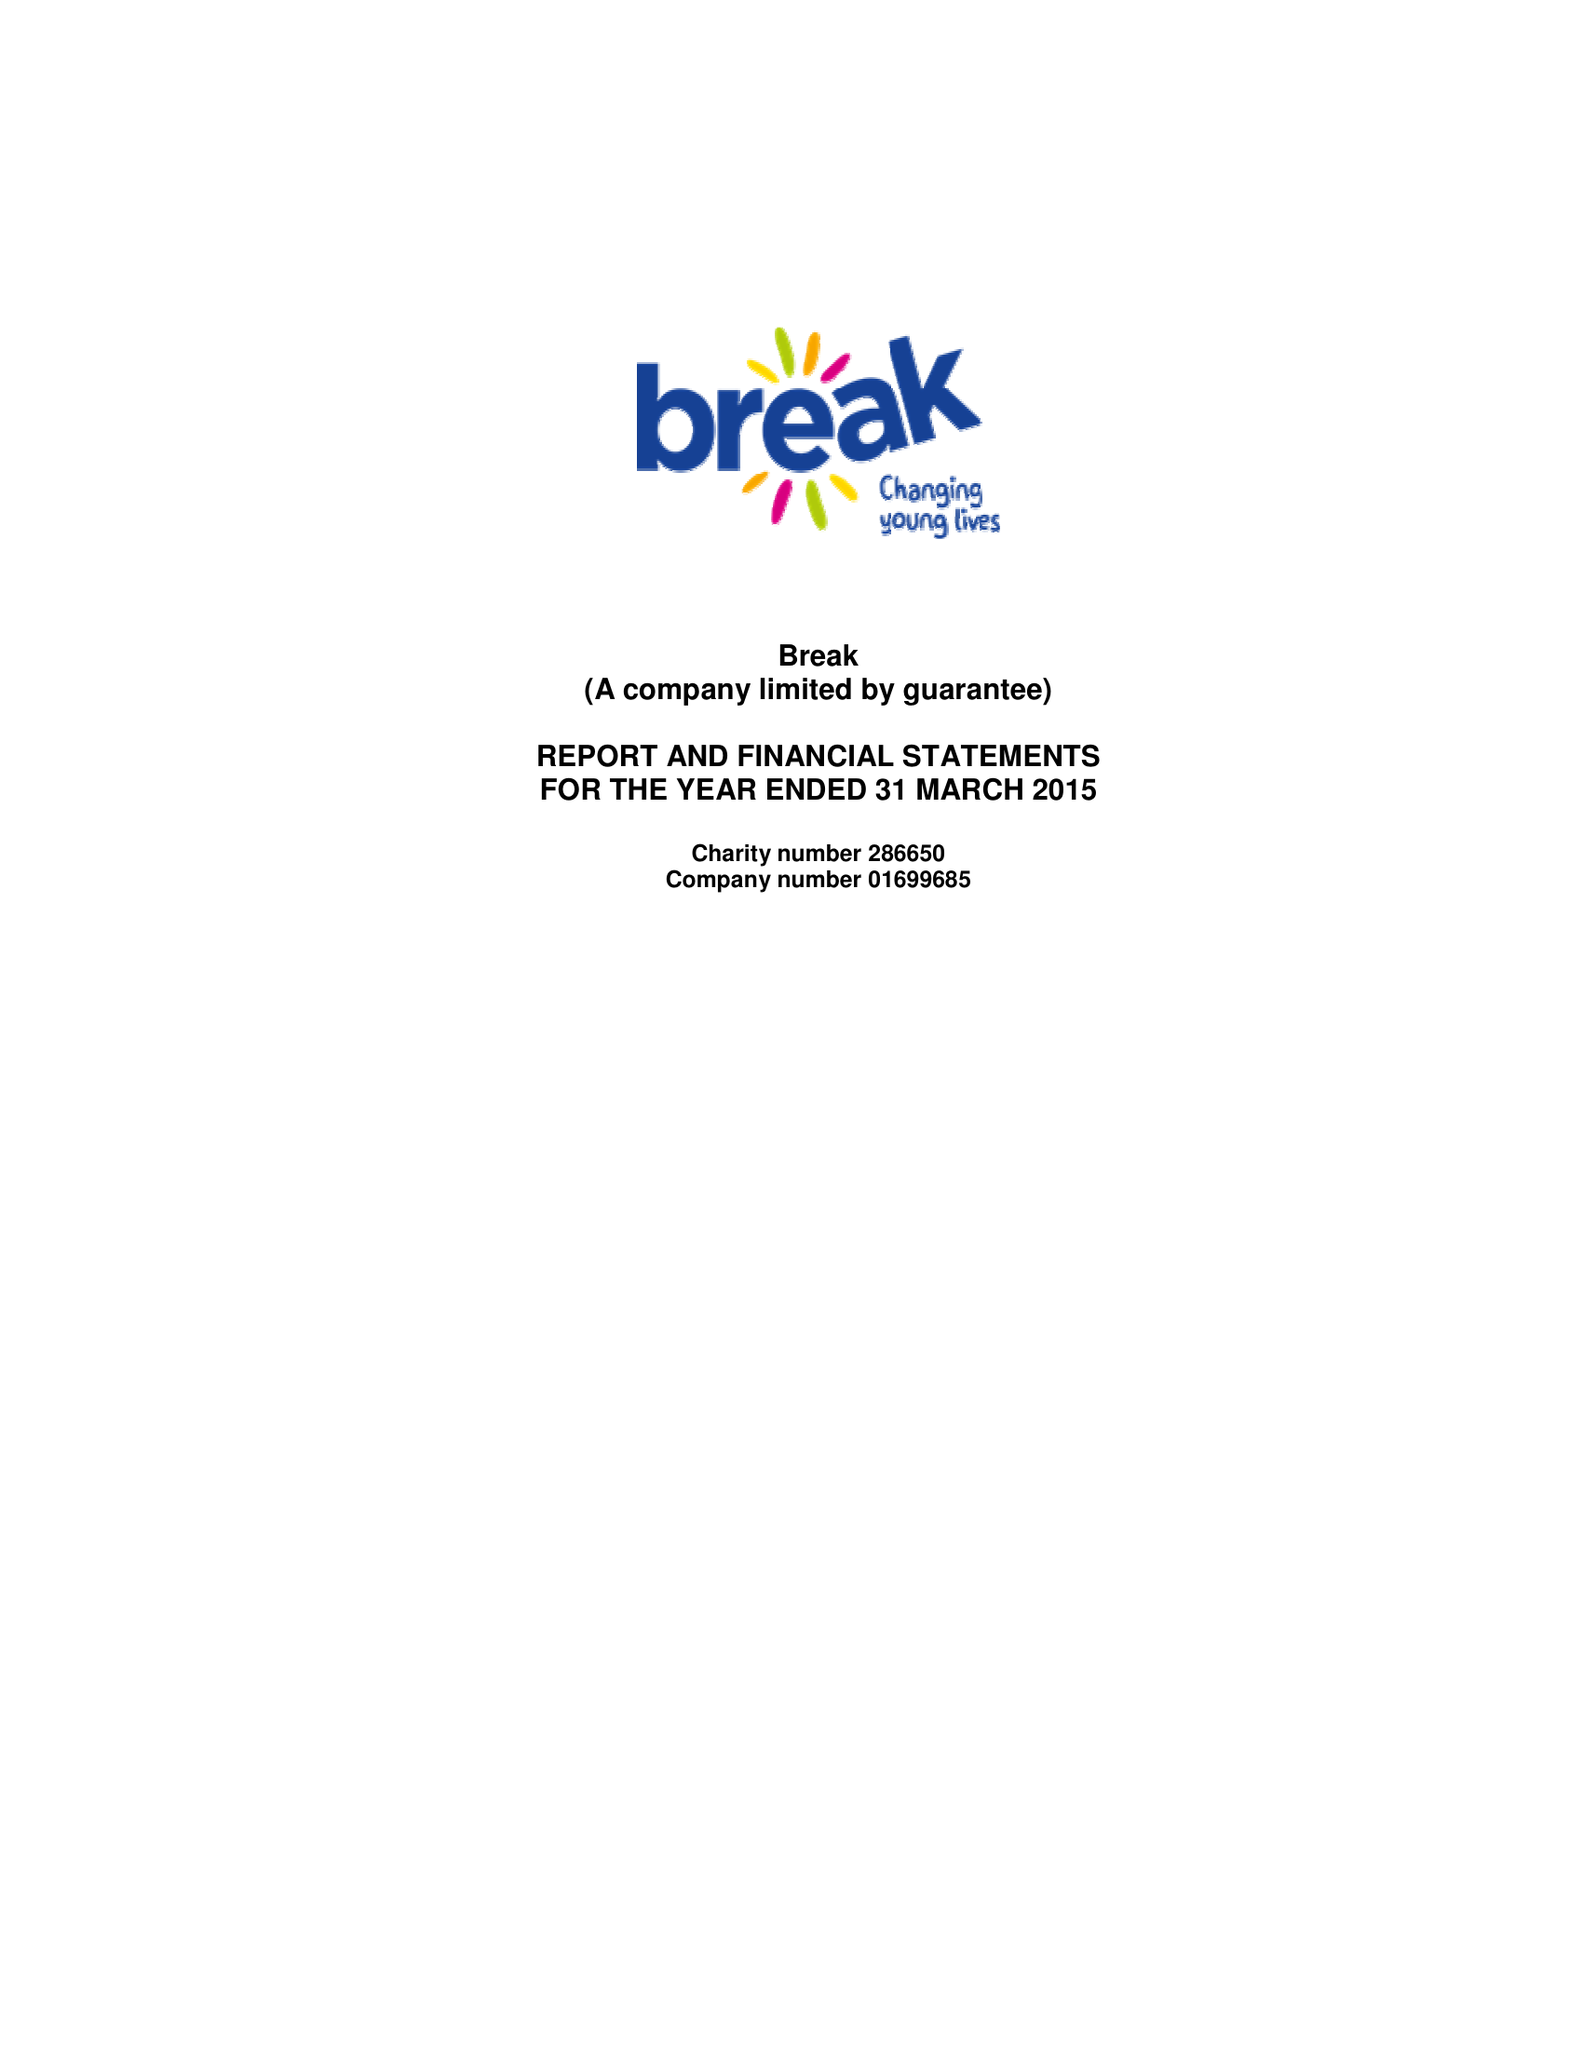What is the value for the spending_annually_in_british_pounds?
Answer the question using a single word or phrase. 10216163.00 